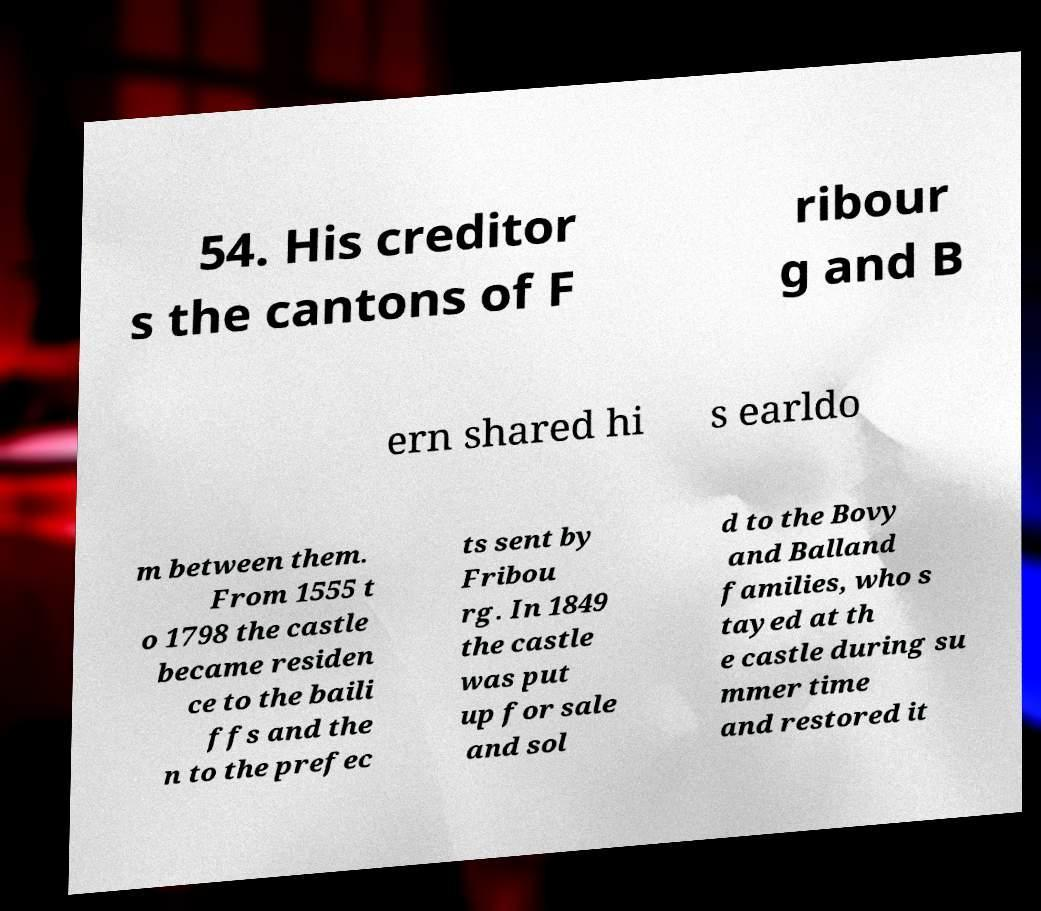Please read and relay the text visible in this image. What does it say? 54. His creditor s the cantons of F ribour g and B ern shared hi s earldo m between them. From 1555 t o 1798 the castle became residen ce to the baili ffs and the n to the prefec ts sent by Fribou rg. In 1849 the castle was put up for sale and sol d to the Bovy and Balland families, who s tayed at th e castle during su mmer time and restored it 